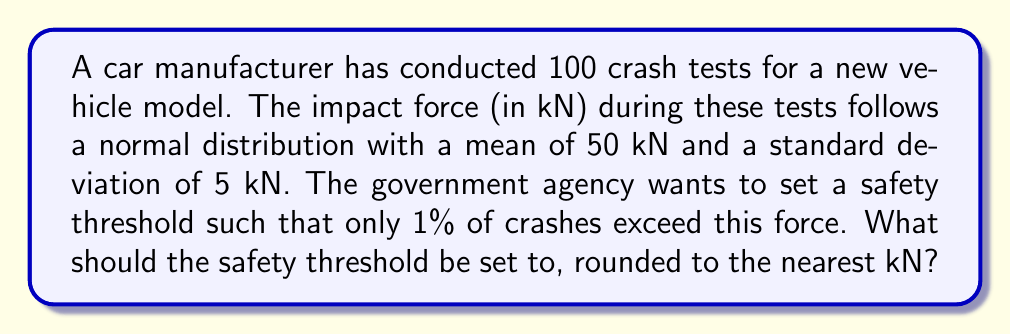Could you help me with this problem? To solve this problem, we need to use the properties of the normal distribution and the concept of z-scores.

Step 1: Identify the given information
- The impact force follows a normal distribution
- Mean (μ) = 50 kN
- Standard deviation (σ) = 5 kN
- We want to find the 99th percentile (as only 1% should exceed the threshold)

Step 2: Determine the z-score for the 99th percentile
The z-score for the 99th percentile is 2.326 (from standard normal distribution tables)

Step 3: Use the z-score formula to calculate the threshold
The z-score formula is:
$$ z = \frac{x - \mu}{\sigma} $$

Rearranging this for x (our threshold):
$$ x = \mu + z\sigma $$

Step 4: Plug in the values
$$ x = 50 + (2.326 \times 5) = 50 + 11.63 = 61.63 \text{ kN} $$

Step 5: Round to the nearest kN
61.63 kN rounds to 62 kN

Therefore, the safety threshold should be set at 62 kN.
Answer: 62 kN 